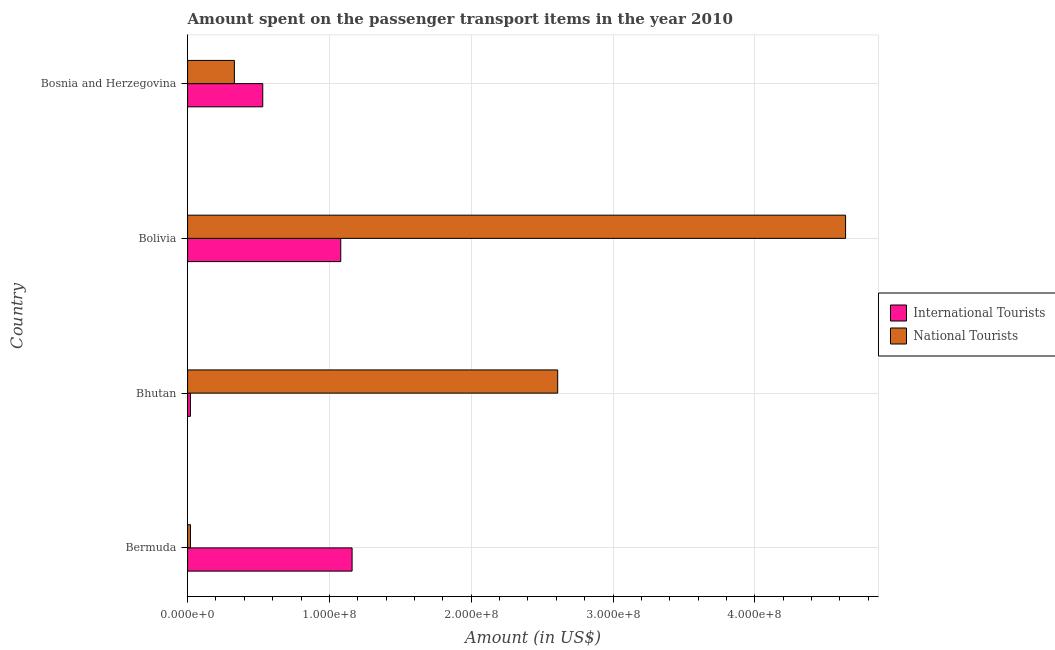How many different coloured bars are there?
Make the answer very short. 2. Are the number of bars on each tick of the Y-axis equal?
Provide a succinct answer. Yes. How many bars are there on the 3rd tick from the top?
Give a very brief answer. 2. How many bars are there on the 1st tick from the bottom?
Make the answer very short. 2. What is the label of the 1st group of bars from the top?
Your response must be concise. Bosnia and Herzegovina. What is the amount spent on transport items of national tourists in Bosnia and Herzegovina?
Your answer should be compact. 3.30e+07. Across all countries, what is the maximum amount spent on transport items of international tourists?
Make the answer very short. 1.16e+08. In which country was the amount spent on transport items of international tourists maximum?
Keep it short and to the point. Bermuda. In which country was the amount spent on transport items of international tourists minimum?
Offer a terse response. Bhutan. What is the total amount spent on transport items of national tourists in the graph?
Provide a succinct answer. 7.60e+08. What is the difference between the amount spent on transport items of national tourists in Bhutan and that in Bolivia?
Ensure brevity in your answer.  -2.03e+08. What is the difference between the amount spent on transport items of international tourists in Bermuda and the amount spent on transport items of national tourists in Bolivia?
Offer a very short reply. -3.48e+08. What is the average amount spent on transport items of international tourists per country?
Give a very brief answer. 6.98e+07. What is the difference between the amount spent on transport items of international tourists and amount spent on transport items of national tourists in Bermuda?
Your response must be concise. 1.14e+08. In how many countries, is the amount spent on transport items of international tourists greater than 260000000 US$?
Your response must be concise. 0. What is the ratio of the amount spent on transport items of national tourists in Bhutan to that in Bolivia?
Ensure brevity in your answer.  0.56. Is the difference between the amount spent on transport items of national tourists in Bolivia and Bosnia and Herzegovina greater than the difference between the amount spent on transport items of international tourists in Bolivia and Bosnia and Herzegovina?
Make the answer very short. Yes. What is the difference between the highest and the lowest amount spent on transport items of international tourists?
Make the answer very short. 1.14e+08. Is the sum of the amount spent on transport items of national tourists in Bermuda and Bhutan greater than the maximum amount spent on transport items of international tourists across all countries?
Your answer should be compact. Yes. What does the 1st bar from the top in Bermuda represents?
Give a very brief answer. National Tourists. What does the 2nd bar from the bottom in Bolivia represents?
Keep it short and to the point. National Tourists. Does the graph contain any zero values?
Offer a very short reply. No. Where does the legend appear in the graph?
Provide a short and direct response. Center right. What is the title of the graph?
Make the answer very short. Amount spent on the passenger transport items in the year 2010. Does "Urban" appear as one of the legend labels in the graph?
Your answer should be compact. No. What is the label or title of the X-axis?
Make the answer very short. Amount (in US$). What is the Amount (in US$) in International Tourists in Bermuda?
Offer a very short reply. 1.16e+08. What is the Amount (in US$) in International Tourists in Bhutan?
Provide a succinct answer. 2.00e+06. What is the Amount (in US$) in National Tourists in Bhutan?
Make the answer very short. 2.61e+08. What is the Amount (in US$) in International Tourists in Bolivia?
Offer a terse response. 1.08e+08. What is the Amount (in US$) in National Tourists in Bolivia?
Offer a terse response. 4.64e+08. What is the Amount (in US$) in International Tourists in Bosnia and Herzegovina?
Ensure brevity in your answer.  5.30e+07. What is the Amount (in US$) of National Tourists in Bosnia and Herzegovina?
Your answer should be compact. 3.30e+07. Across all countries, what is the maximum Amount (in US$) in International Tourists?
Ensure brevity in your answer.  1.16e+08. Across all countries, what is the maximum Amount (in US$) of National Tourists?
Your answer should be compact. 4.64e+08. Across all countries, what is the minimum Amount (in US$) of International Tourists?
Offer a terse response. 2.00e+06. Across all countries, what is the minimum Amount (in US$) in National Tourists?
Make the answer very short. 2.00e+06. What is the total Amount (in US$) of International Tourists in the graph?
Provide a succinct answer. 2.79e+08. What is the total Amount (in US$) of National Tourists in the graph?
Provide a short and direct response. 7.60e+08. What is the difference between the Amount (in US$) in International Tourists in Bermuda and that in Bhutan?
Provide a succinct answer. 1.14e+08. What is the difference between the Amount (in US$) of National Tourists in Bermuda and that in Bhutan?
Offer a very short reply. -2.59e+08. What is the difference between the Amount (in US$) in International Tourists in Bermuda and that in Bolivia?
Your response must be concise. 8.00e+06. What is the difference between the Amount (in US$) in National Tourists in Bermuda and that in Bolivia?
Your response must be concise. -4.62e+08. What is the difference between the Amount (in US$) in International Tourists in Bermuda and that in Bosnia and Herzegovina?
Provide a succinct answer. 6.30e+07. What is the difference between the Amount (in US$) of National Tourists in Bermuda and that in Bosnia and Herzegovina?
Offer a very short reply. -3.10e+07. What is the difference between the Amount (in US$) of International Tourists in Bhutan and that in Bolivia?
Your answer should be very brief. -1.06e+08. What is the difference between the Amount (in US$) in National Tourists in Bhutan and that in Bolivia?
Provide a short and direct response. -2.03e+08. What is the difference between the Amount (in US$) in International Tourists in Bhutan and that in Bosnia and Herzegovina?
Keep it short and to the point. -5.10e+07. What is the difference between the Amount (in US$) in National Tourists in Bhutan and that in Bosnia and Herzegovina?
Your response must be concise. 2.28e+08. What is the difference between the Amount (in US$) of International Tourists in Bolivia and that in Bosnia and Herzegovina?
Your response must be concise. 5.50e+07. What is the difference between the Amount (in US$) of National Tourists in Bolivia and that in Bosnia and Herzegovina?
Offer a very short reply. 4.31e+08. What is the difference between the Amount (in US$) in International Tourists in Bermuda and the Amount (in US$) in National Tourists in Bhutan?
Ensure brevity in your answer.  -1.45e+08. What is the difference between the Amount (in US$) of International Tourists in Bermuda and the Amount (in US$) of National Tourists in Bolivia?
Your answer should be compact. -3.48e+08. What is the difference between the Amount (in US$) of International Tourists in Bermuda and the Amount (in US$) of National Tourists in Bosnia and Herzegovina?
Provide a succinct answer. 8.30e+07. What is the difference between the Amount (in US$) of International Tourists in Bhutan and the Amount (in US$) of National Tourists in Bolivia?
Ensure brevity in your answer.  -4.62e+08. What is the difference between the Amount (in US$) in International Tourists in Bhutan and the Amount (in US$) in National Tourists in Bosnia and Herzegovina?
Give a very brief answer. -3.10e+07. What is the difference between the Amount (in US$) of International Tourists in Bolivia and the Amount (in US$) of National Tourists in Bosnia and Herzegovina?
Make the answer very short. 7.50e+07. What is the average Amount (in US$) in International Tourists per country?
Your answer should be compact. 6.98e+07. What is the average Amount (in US$) in National Tourists per country?
Give a very brief answer. 1.90e+08. What is the difference between the Amount (in US$) of International Tourists and Amount (in US$) of National Tourists in Bermuda?
Provide a short and direct response. 1.14e+08. What is the difference between the Amount (in US$) of International Tourists and Amount (in US$) of National Tourists in Bhutan?
Provide a succinct answer. -2.59e+08. What is the difference between the Amount (in US$) of International Tourists and Amount (in US$) of National Tourists in Bolivia?
Keep it short and to the point. -3.56e+08. What is the difference between the Amount (in US$) of International Tourists and Amount (in US$) of National Tourists in Bosnia and Herzegovina?
Offer a terse response. 2.00e+07. What is the ratio of the Amount (in US$) of International Tourists in Bermuda to that in Bhutan?
Your response must be concise. 58. What is the ratio of the Amount (in US$) of National Tourists in Bermuda to that in Bhutan?
Give a very brief answer. 0.01. What is the ratio of the Amount (in US$) in International Tourists in Bermuda to that in Bolivia?
Make the answer very short. 1.07. What is the ratio of the Amount (in US$) of National Tourists in Bermuda to that in Bolivia?
Ensure brevity in your answer.  0. What is the ratio of the Amount (in US$) of International Tourists in Bermuda to that in Bosnia and Herzegovina?
Offer a terse response. 2.19. What is the ratio of the Amount (in US$) of National Tourists in Bermuda to that in Bosnia and Herzegovina?
Keep it short and to the point. 0.06. What is the ratio of the Amount (in US$) of International Tourists in Bhutan to that in Bolivia?
Your answer should be very brief. 0.02. What is the ratio of the Amount (in US$) of National Tourists in Bhutan to that in Bolivia?
Make the answer very short. 0.56. What is the ratio of the Amount (in US$) in International Tourists in Bhutan to that in Bosnia and Herzegovina?
Give a very brief answer. 0.04. What is the ratio of the Amount (in US$) in National Tourists in Bhutan to that in Bosnia and Herzegovina?
Your response must be concise. 7.91. What is the ratio of the Amount (in US$) of International Tourists in Bolivia to that in Bosnia and Herzegovina?
Offer a very short reply. 2.04. What is the ratio of the Amount (in US$) in National Tourists in Bolivia to that in Bosnia and Herzegovina?
Your response must be concise. 14.06. What is the difference between the highest and the second highest Amount (in US$) of National Tourists?
Offer a very short reply. 2.03e+08. What is the difference between the highest and the lowest Amount (in US$) in International Tourists?
Provide a short and direct response. 1.14e+08. What is the difference between the highest and the lowest Amount (in US$) in National Tourists?
Ensure brevity in your answer.  4.62e+08. 